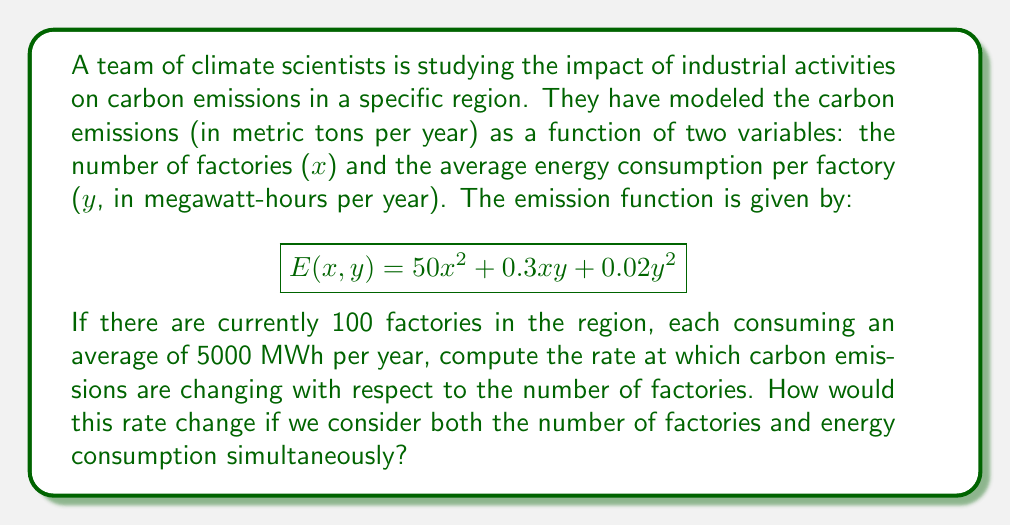Can you solve this math problem? To solve this problem, we'll use partial derivatives and the gradient vector from multivariable calculus.

Step 1: Calculate the partial derivative with respect to x (number of factories).
$$\frac{\partial E}{\partial x} = 100x + 0.3y$$

Step 2: Calculate the partial derivative with respect to y (energy consumption).
$$\frac{\partial E}{\partial y} = 0.3x + 0.04y$$

Step 3: Evaluate the rate of change with respect to x at the given point (100, 5000).
$$\frac{\partial E}{\partial x}\bigg|_{(100,5000)} = 100(100) + 0.3(5000) = 11500$$

This means that at the current state, adding one more factory would increase carbon emissions by approximately 11,500 metric tons per year.

Step 4: To consider both variables simultaneously, we use the gradient vector:
$$\nabla E = \left(\frac{\partial E}{\partial x}, \frac{\partial E}{\partial y}\right) = (100x + 0.3y, 0.3x + 0.04y)$$

Step 5: Evaluate the gradient vector at the given point (100, 5000).
$$\nabla E\bigg|_{(100,5000)} = (11500, 230)$$

This gradient vector tells us that at the current state:
1. Increasing the number of factories has a much larger impact on emissions than increasing energy consumption.
2. The rate of change with respect to the number of factories (11,500) is the same as we calculated earlier.
3. The rate of change with respect to energy consumption is 230, meaning that for each additional MWh of energy consumed across all factories, emissions would increase by 230 metric tons per year.
Answer: 11,500 metric tons per year per factory; gradient (11500, 230) 